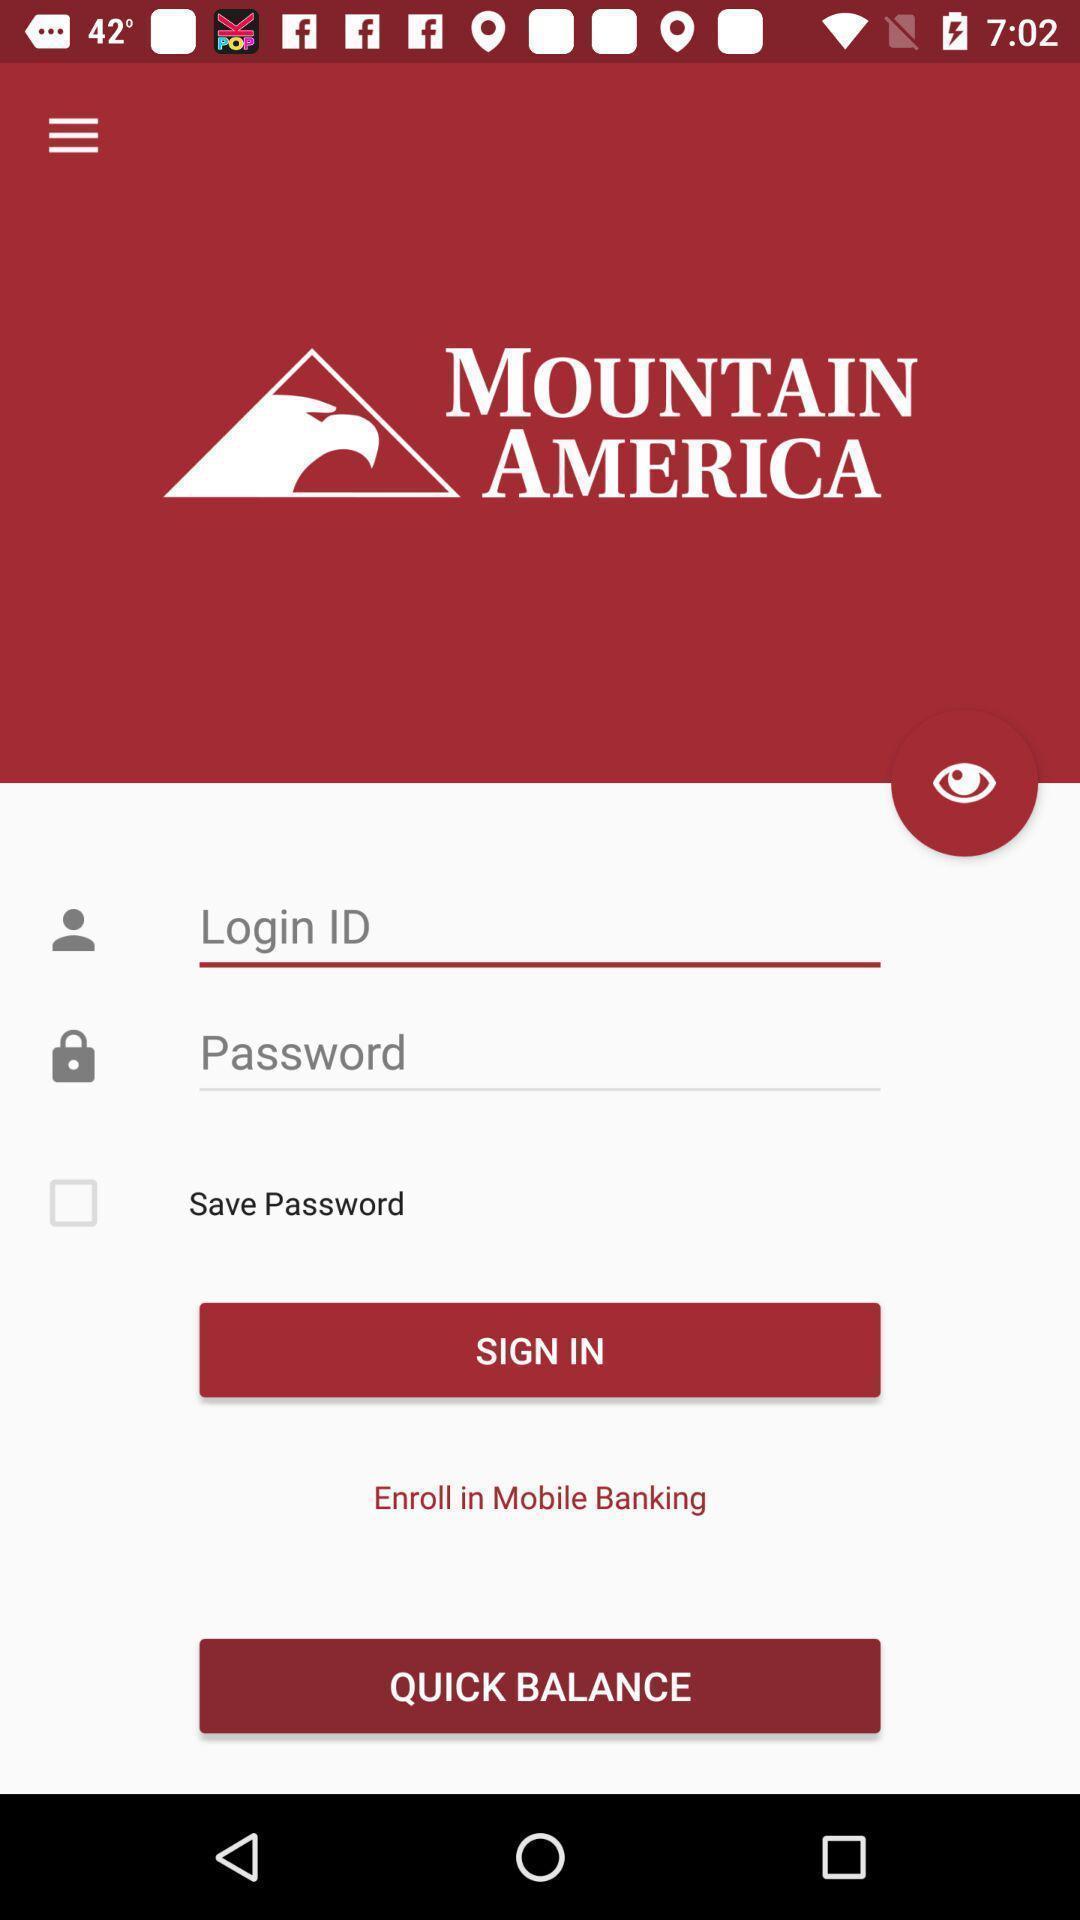Summarize the main components in this picture. Welcome to the login page. 